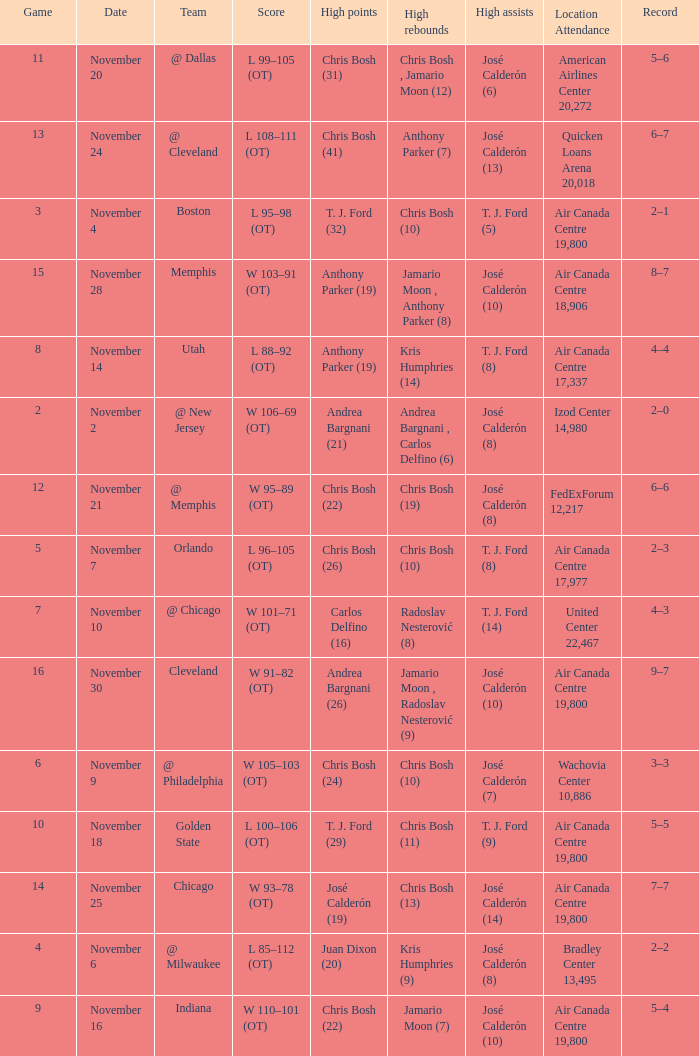Who had the high rebounds when the game number was 6? Chris Bosh (10). 